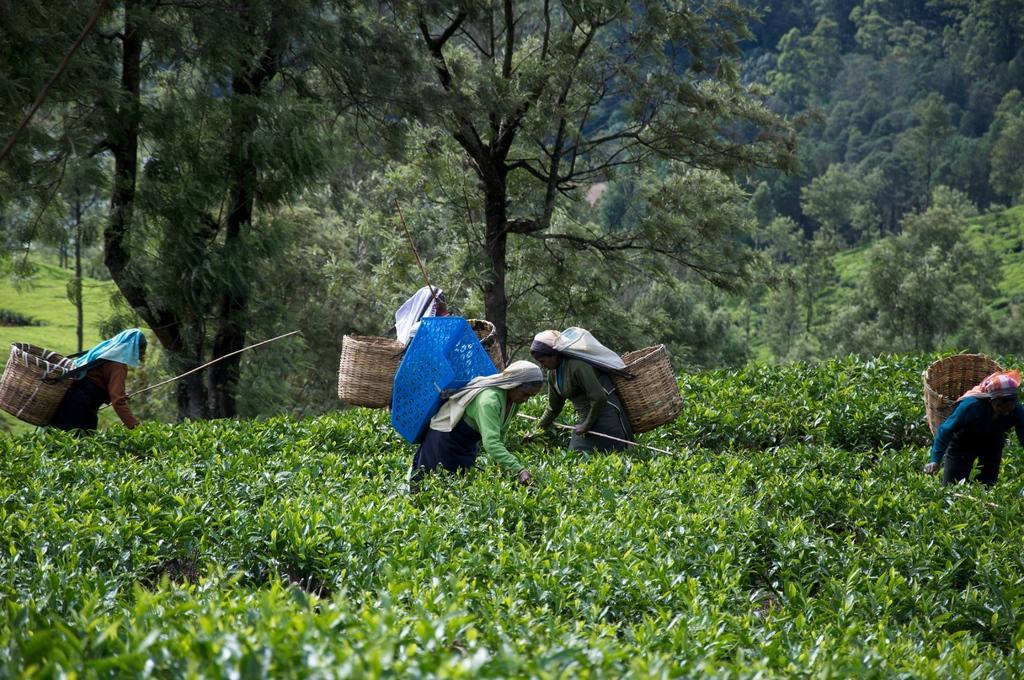In one or two sentences, can you explain what this image depicts? In the image we can see there are many people standing, wearing clothes and they are carrying a wooden basket. Here we can see tea plants, grass and trees. 